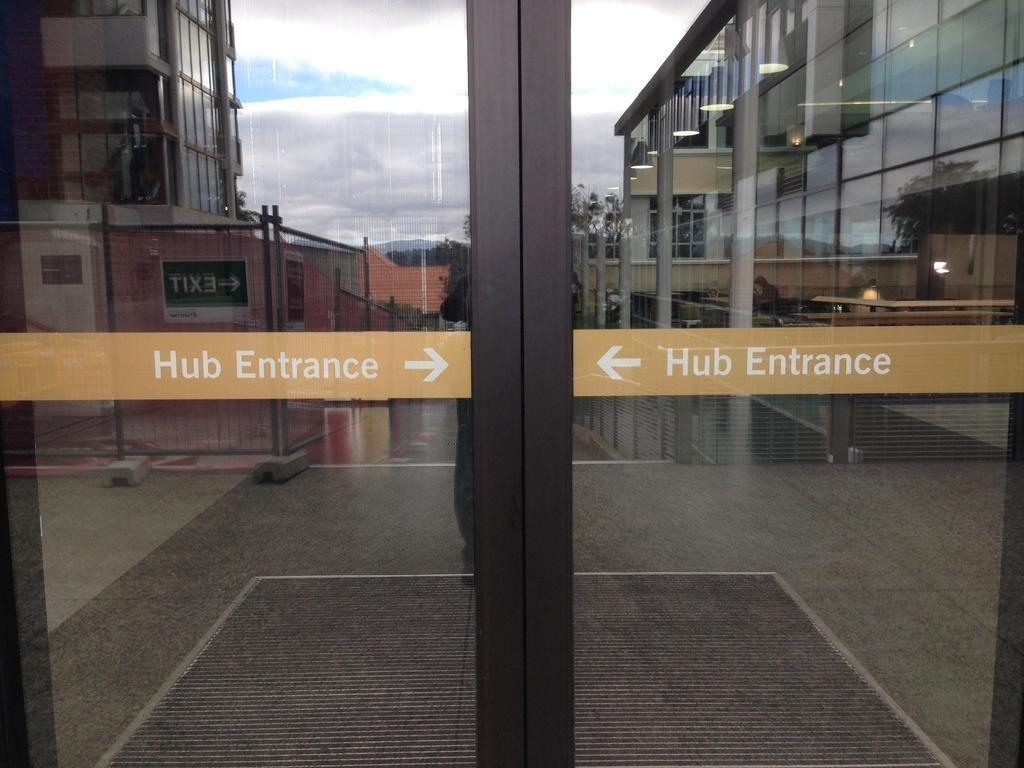In one or two sentences, can you explain what this image depicts? In the image there are doors with glasses and some stickers on it. On the glass door there is a reflection of a few buildings, pillars, lights, trees, sky and fencing. At the bottom of the glass door there is a mat. 